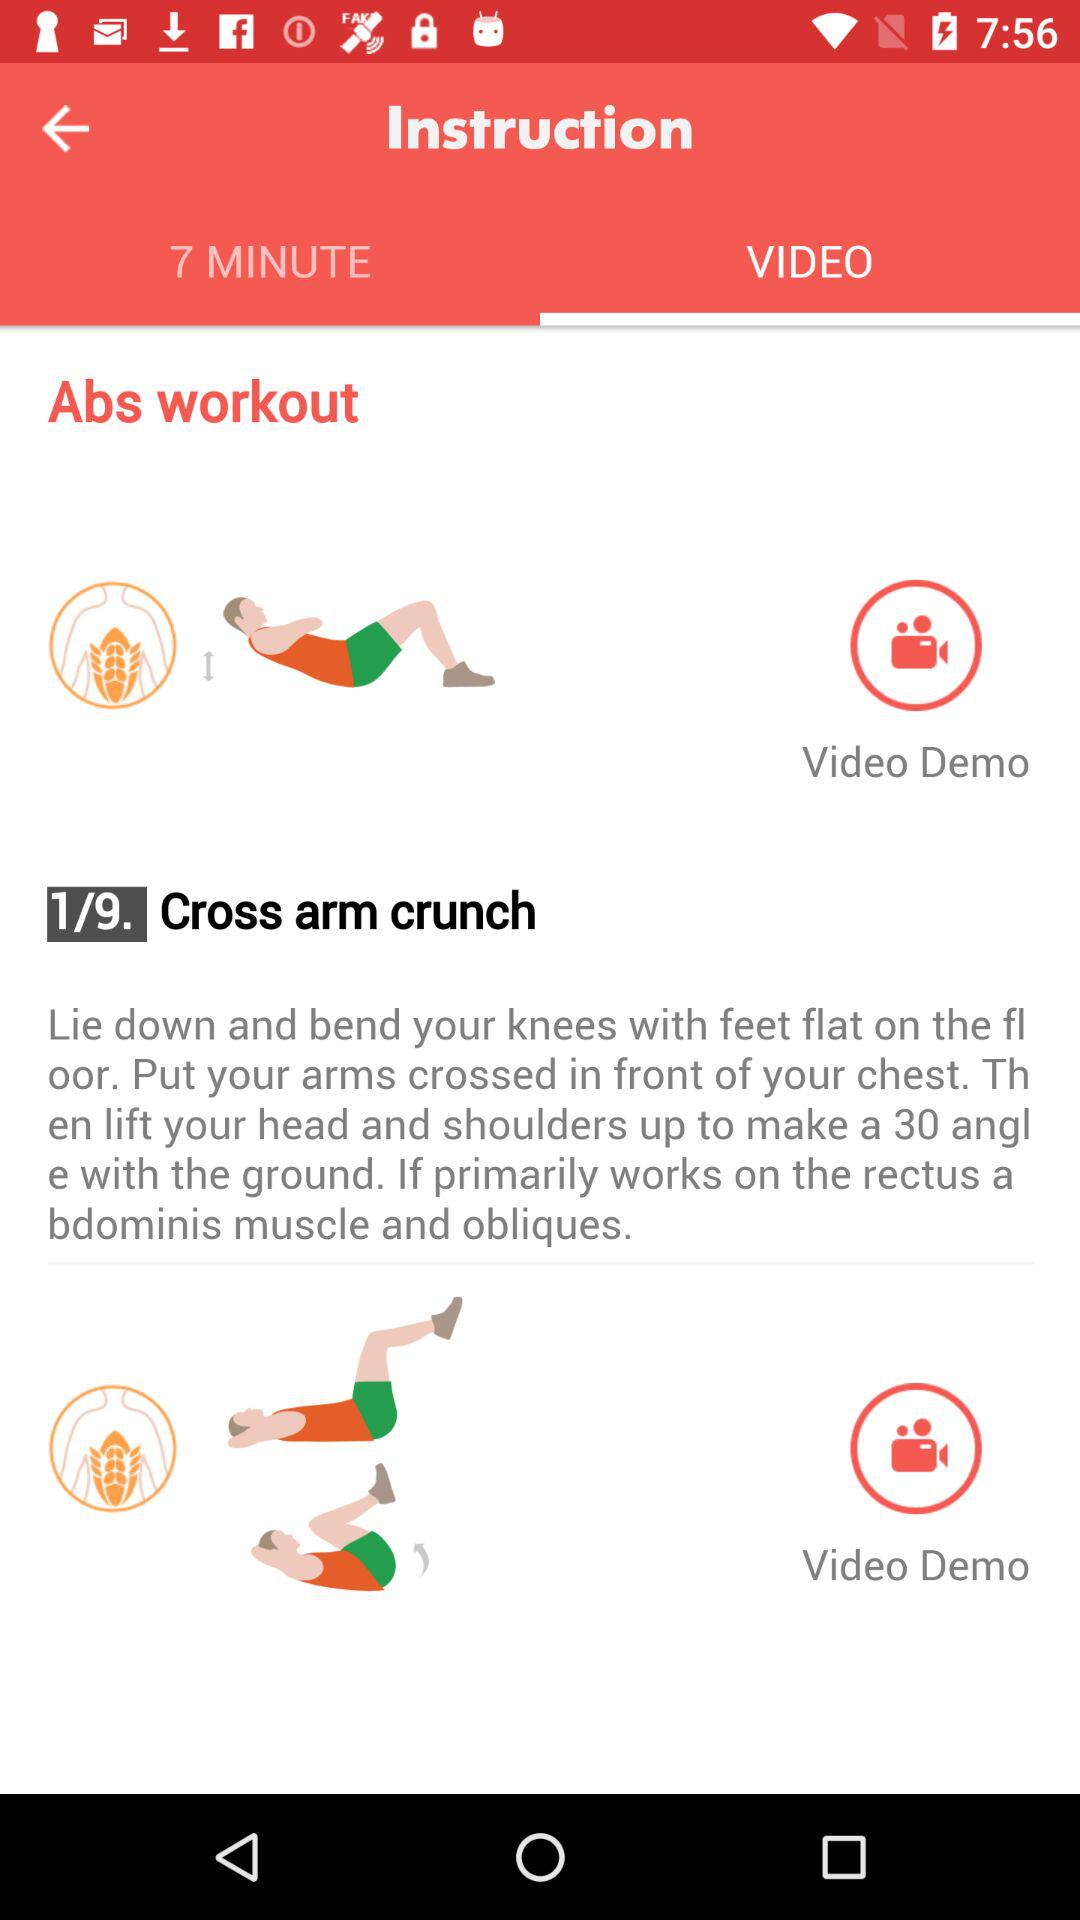Which tab is selected? The selected tab is "VIDEO". 